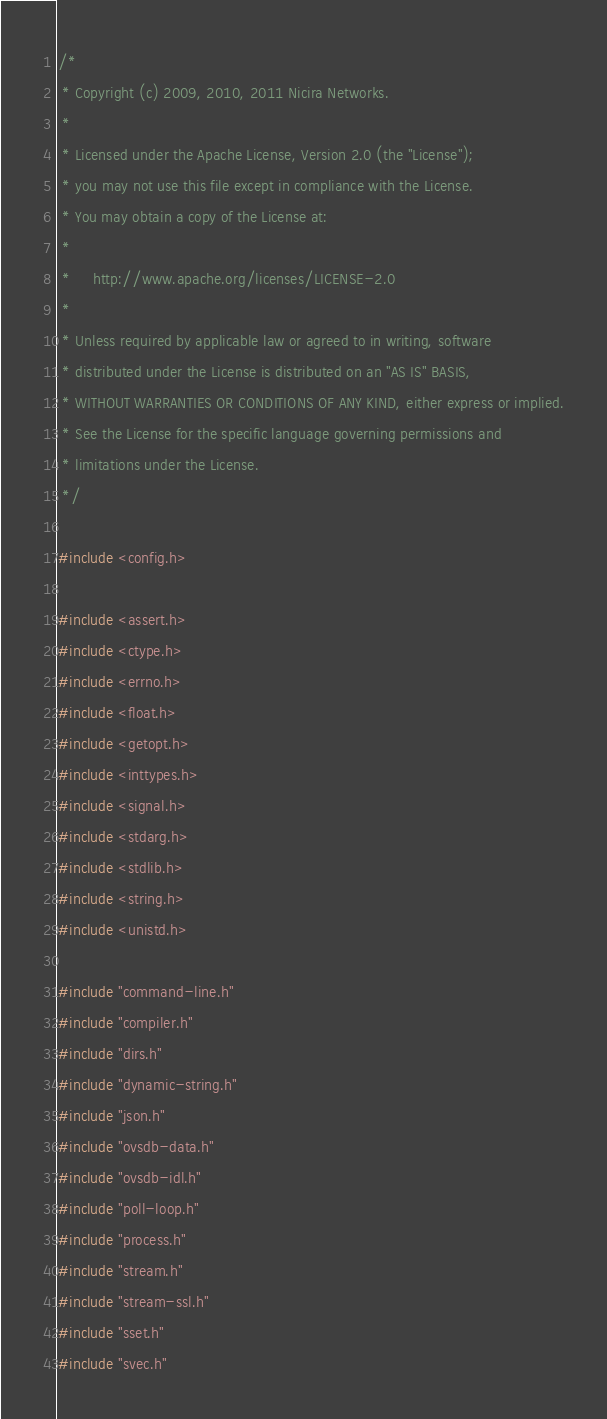Convert code to text. <code><loc_0><loc_0><loc_500><loc_500><_C_>/*
 * Copyright (c) 2009, 2010, 2011 Nicira Networks.
 *
 * Licensed under the Apache License, Version 2.0 (the "License");
 * you may not use this file except in compliance with the License.
 * You may obtain a copy of the License at:
 *
 *     http://www.apache.org/licenses/LICENSE-2.0
 *
 * Unless required by applicable law or agreed to in writing, software
 * distributed under the License is distributed on an "AS IS" BASIS,
 * WITHOUT WARRANTIES OR CONDITIONS OF ANY KIND, either express or implied.
 * See the License for the specific language governing permissions and
 * limitations under the License.
 */

#include <config.h>

#include <assert.h>
#include <ctype.h>
#include <errno.h>
#include <float.h>
#include <getopt.h>
#include <inttypes.h>
#include <signal.h>
#include <stdarg.h>
#include <stdlib.h>
#include <string.h>
#include <unistd.h>

#include "command-line.h"
#include "compiler.h"
#include "dirs.h"
#include "dynamic-string.h"
#include "json.h"
#include "ovsdb-data.h"
#include "ovsdb-idl.h"
#include "poll-loop.h"
#include "process.h"
#include "stream.h"
#include "stream-ssl.h"
#include "sset.h"
#include "svec.h"</code> 